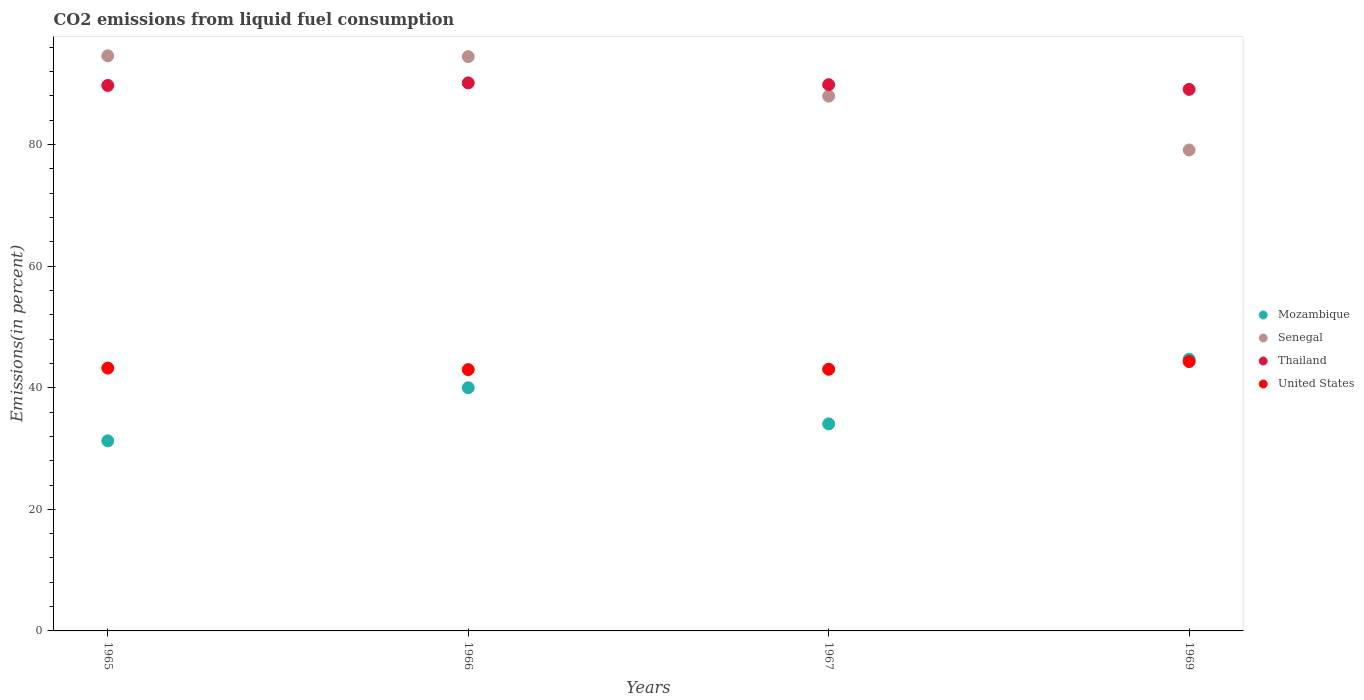How many different coloured dotlines are there?
Provide a succinct answer. 4. What is the total CO2 emitted in United States in 1969?
Make the answer very short. 44.3. Across all years, what is the maximum total CO2 emitted in Mozambique?
Your answer should be compact. 44.68. Across all years, what is the minimum total CO2 emitted in Mozambique?
Make the answer very short. 31.26. In which year was the total CO2 emitted in Senegal maximum?
Keep it short and to the point. 1965. In which year was the total CO2 emitted in Senegal minimum?
Provide a succinct answer. 1969. What is the total total CO2 emitted in United States in the graph?
Offer a terse response. 173.55. What is the difference between the total CO2 emitted in Mozambique in 1965 and that in 1967?
Your answer should be very brief. -2.79. What is the difference between the total CO2 emitted in Thailand in 1969 and the total CO2 emitted in United States in 1965?
Make the answer very short. 45.84. What is the average total CO2 emitted in United States per year?
Make the answer very short. 43.39. In the year 1969, what is the difference between the total CO2 emitted in Thailand and total CO2 emitted in Senegal?
Your answer should be compact. 9.97. In how many years, is the total CO2 emitted in United States greater than 92 %?
Keep it short and to the point. 0. What is the ratio of the total CO2 emitted in Mozambique in 1965 to that in 1966?
Offer a terse response. 0.78. Is the total CO2 emitted in United States in 1965 less than that in 1966?
Give a very brief answer. No. Is the difference between the total CO2 emitted in Thailand in 1965 and 1967 greater than the difference between the total CO2 emitted in Senegal in 1965 and 1967?
Offer a very short reply. No. What is the difference between the highest and the second highest total CO2 emitted in Senegal?
Offer a very short reply. 0.13. What is the difference between the highest and the lowest total CO2 emitted in Thailand?
Your answer should be very brief. 1.06. Is it the case that in every year, the sum of the total CO2 emitted in Senegal and total CO2 emitted in United States  is greater than the sum of total CO2 emitted in Mozambique and total CO2 emitted in Thailand?
Provide a succinct answer. No. Is it the case that in every year, the sum of the total CO2 emitted in Mozambique and total CO2 emitted in United States  is greater than the total CO2 emitted in Thailand?
Your answer should be very brief. No. Does the total CO2 emitted in Thailand monotonically increase over the years?
Provide a short and direct response. No. Is the total CO2 emitted in United States strictly less than the total CO2 emitted in Mozambique over the years?
Provide a short and direct response. No. How many dotlines are there?
Give a very brief answer. 4. How many years are there in the graph?
Ensure brevity in your answer.  4. What is the difference between two consecutive major ticks on the Y-axis?
Offer a terse response. 20. Are the values on the major ticks of Y-axis written in scientific E-notation?
Give a very brief answer. No. Does the graph contain any zero values?
Ensure brevity in your answer.  No. Where does the legend appear in the graph?
Your response must be concise. Center right. How many legend labels are there?
Provide a succinct answer. 4. How are the legend labels stacked?
Give a very brief answer. Vertical. What is the title of the graph?
Make the answer very short. CO2 emissions from liquid fuel consumption. What is the label or title of the Y-axis?
Your answer should be compact. Emissions(in percent). What is the Emissions(in percent) of Mozambique in 1965?
Your response must be concise. 31.26. What is the Emissions(in percent) in Senegal in 1965?
Keep it short and to the point. 94.59. What is the Emissions(in percent) in Thailand in 1965?
Offer a terse response. 89.71. What is the Emissions(in percent) of United States in 1965?
Your answer should be very brief. 43.23. What is the Emissions(in percent) of Senegal in 1966?
Give a very brief answer. 94.46. What is the Emissions(in percent) of Thailand in 1966?
Keep it short and to the point. 90.14. What is the Emissions(in percent) in United States in 1966?
Make the answer very short. 42.98. What is the Emissions(in percent) in Mozambique in 1967?
Make the answer very short. 34.05. What is the Emissions(in percent) in Senegal in 1967?
Provide a succinct answer. 87.96. What is the Emissions(in percent) of Thailand in 1967?
Your answer should be very brief. 89.84. What is the Emissions(in percent) of United States in 1967?
Ensure brevity in your answer.  43.04. What is the Emissions(in percent) of Mozambique in 1969?
Your answer should be compact. 44.68. What is the Emissions(in percent) in Senegal in 1969?
Provide a succinct answer. 79.1. What is the Emissions(in percent) of Thailand in 1969?
Offer a terse response. 89.07. What is the Emissions(in percent) of United States in 1969?
Make the answer very short. 44.3. Across all years, what is the maximum Emissions(in percent) in Mozambique?
Offer a terse response. 44.68. Across all years, what is the maximum Emissions(in percent) of Senegal?
Keep it short and to the point. 94.59. Across all years, what is the maximum Emissions(in percent) of Thailand?
Ensure brevity in your answer.  90.14. Across all years, what is the maximum Emissions(in percent) of United States?
Your answer should be very brief. 44.3. Across all years, what is the minimum Emissions(in percent) in Mozambique?
Provide a succinct answer. 31.26. Across all years, what is the minimum Emissions(in percent) of Senegal?
Make the answer very short. 79.1. Across all years, what is the minimum Emissions(in percent) in Thailand?
Keep it short and to the point. 89.07. Across all years, what is the minimum Emissions(in percent) in United States?
Offer a very short reply. 42.98. What is the total Emissions(in percent) of Mozambique in the graph?
Ensure brevity in your answer.  150. What is the total Emissions(in percent) in Senegal in the graph?
Keep it short and to the point. 356.11. What is the total Emissions(in percent) in Thailand in the graph?
Provide a short and direct response. 358.76. What is the total Emissions(in percent) in United States in the graph?
Give a very brief answer. 173.55. What is the difference between the Emissions(in percent) in Mozambique in 1965 and that in 1966?
Give a very brief answer. -8.74. What is the difference between the Emissions(in percent) in Senegal in 1965 and that in 1966?
Make the answer very short. 0.13. What is the difference between the Emissions(in percent) in Thailand in 1965 and that in 1966?
Ensure brevity in your answer.  -0.42. What is the difference between the Emissions(in percent) of United States in 1965 and that in 1966?
Ensure brevity in your answer.  0.25. What is the difference between the Emissions(in percent) in Mozambique in 1965 and that in 1967?
Provide a succinct answer. -2.79. What is the difference between the Emissions(in percent) of Senegal in 1965 and that in 1967?
Your answer should be compact. 6.63. What is the difference between the Emissions(in percent) in Thailand in 1965 and that in 1967?
Give a very brief answer. -0.13. What is the difference between the Emissions(in percent) in United States in 1965 and that in 1967?
Keep it short and to the point. 0.19. What is the difference between the Emissions(in percent) of Mozambique in 1965 and that in 1969?
Your response must be concise. -13.42. What is the difference between the Emissions(in percent) in Senegal in 1965 and that in 1969?
Keep it short and to the point. 15.48. What is the difference between the Emissions(in percent) of Thailand in 1965 and that in 1969?
Offer a terse response. 0.64. What is the difference between the Emissions(in percent) of United States in 1965 and that in 1969?
Provide a succinct answer. -1.07. What is the difference between the Emissions(in percent) of Mozambique in 1966 and that in 1967?
Keep it short and to the point. 5.95. What is the difference between the Emissions(in percent) in Senegal in 1966 and that in 1967?
Keep it short and to the point. 6.5. What is the difference between the Emissions(in percent) of Thailand in 1966 and that in 1967?
Ensure brevity in your answer.  0.29. What is the difference between the Emissions(in percent) in United States in 1966 and that in 1967?
Offer a terse response. -0.06. What is the difference between the Emissions(in percent) of Mozambique in 1966 and that in 1969?
Offer a terse response. -4.68. What is the difference between the Emissions(in percent) in Senegal in 1966 and that in 1969?
Provide a short and direct response. 15.35. What is the difference between the Emissions(in percent) in Thailand in 1966 and that in 1969?
Provide a short and direct response. 1.06. What is the difference between the Emissions(in percent) in United States in 1966 and that in 1969?
Offer a terse response. -1.32. What is the difference between the Emissions(in percent) of Mozambique in 1967 and that in 1969?
Your answer should be very brief. -10.63. What is the difference between the Emissions(in percent) of Senegal in 1967 and that in 1969?
Give a very brief answer. 8.85. What is the difference between the Emissions(in percent) of Thailand in 1967 and that in 1969?
Offer a terse response. 0.77. What is the difference between the Emissions(in percent) of United States in 1967 and that in 1969?
Keep it short and to the point. -1.27. What is the difference between the Emissions(in percent) of Mozambique in 1965 and the Emissions(in percent) of Senegal in 1966?
Offer a terse response. -63.19. What is the difference between the Emissions(in percent) in Mozambique in 1965 and the Emissions(in percent) in Thailand in 1966?
Ensure brevity in your answer.  -58.87. What is the difference between the Emissions(in percent) of Mozambique in 1965 and the Emissions(in percent) of United States in 1966?
Offer a terse response. -11.72. What is the difference between the Emissions(in percent) in Senegal in 1965 and the Emissions(in percent) in Thailand in 1966?
Offer a very short reply. 4.45. What is the difference between the Emissions(in percent) of Senegal in 1965 and the Emissions(in percent) of United States in 1966?
Your answer should be very brief. 51.61. What is the difference between the Emissions(in percent) in Thailand in 1965 and the Emissions(in percent) in United States in 1966?
Give a very brief answer. 46.73. What is the difference between the Emissions(in percent) in Mozambique in 1965 and the Emissions(in percent) in Senegal in 1967?
Your response must be concise. -56.7. What is the difference between the Emissions(in percent) in Mozambique in 1965 and the Emissions(in percent) in Thailand in 1967?
Offer a very short reply. -58.58. What is the difference between the Emissions(in percent) of Mozambique in 1965 and the Emissions(in percent) of United States in 1967?
Your answer should be very brief. -11.77. What is the difference between the Emissions(in percent) in Senegal in 1965 and the Emissions(in percent) in Thailand in 1967?
Your answer should be very brief. 4.75. What is the difference between the Emissions(in percent) in Senegal in 1965 and the Emissions(in percent) in United States in 1967?
Provide a succinct answer. 51.55. What is the difference between the Emissions(in percent) of Thailand in 1965 and the Emissions(in percent) of United States in 1967?
Keep it short and to the point. 46.68. What is the difference between the Emissions(in percent) of Mozambique in 1965 and the Emissions(in percent) of Senegal in 1969?
Provide a succinct answer. -47.84. What is the difference between the Emissions(in percent) in Mozambique in 1965 and the Emissions(in percent) in Thailand in 1969?
Offer a very short reply. -57.81. What is the difference between the Emissions(in percent) in Mozambique in 1965 and the Emissions(in percent) in United States in 1969?
Your response must be concise. -13.04. What is the difference between the Emissions(in percent) of Senegal in 1965 and the Emissions(in percent) of Thailand in 1969?
Provide a succinct answer. 5.52. What is the difference between the Emissions(in percent) in Senegal in 1965 and the Emissions(in percent) in United States in 1969?
Provide a short and direct response. 50.29. What is the difference between the Emissions(in percent) of Thailand in 1965 and the Emissions(in percent) of United States in 1969?
Give a very brief answer. 45.41. What is the difference between the Emissions(in percent) in Mozambique in 1966 and the Emissions(in percent) in Senegal in 1967?
Your response must be concise. -47.96. What is the difference between the Emissions(in percent) in Mozambique in 1966 and the Emissions(in percent) in Thailand in 1967?
Your response must be concise. -49.84. What is the difference between the Emissions(in percent) of Mozambique in 1966 and the Emissions(in percent) of United States in 1967?
Give a very brief answer. -3.04. What is the difference between the Emissions(in percent) in Senegal in 1966 and the Emissions(in percent) in Thailand in 1967?
Offer a very short reply. 4.61. What is the difference between the Emissions(in percent) in Senegal in 1966 and the Emissions(in percent) in United States in 1967?
Your answer should be very brief. 51.42. What is the difference between the Emissions(in percent) in Thailand in 1966 and the Emissions(in percent) in United States in 1967?
Your answer should be compact. 47.1. What is the difference between the Emissions(in percent) in Mozambique in 1966 and the Emissions(in percent) in Senegal in 1969?
Keep it short and to the point. -39.1. What is the difference between the Emissions(in percent) in Mozambique in 1966 and the Emissions(in percent) in Thailand in 1969?
Offer a very short reply. -49.07. What is the difference between the Emissions(in percent) in Mozambique in 1966 and the Emissions(in percent) in United States in 1969?
Make the answer very short. -4.3. What is the difference between the Emissions(in percent) of Senegal in 1966 and the Emissions(in percent) of Thailand in 1969?
Provide a short and direct response. 5.39. What is the difference between the Emissions(in percent) in Senegal in 1966 and the Emissions(in percent) in United States in 1969?
Make the answer very short. 50.15. What is the difference between the Emissions(in percent) of Thailand in 1966 and the Emissions(in percent) of United States in 1969?
Ensure brevity in your answer.  45.83. What is the difference between the Emissions(in percent) of Mozambique in 1967 and the Emissions(in percent) of Senegal in 1969?
Provide a succinct answer. -45.05. What is the difference between the Emissions(in percent) in Mozambique in 1967 and the Emissions(in percent) in Thailand in 1969?
Provide a succinct answer. -55.02. What is the difference between the Emissions(in percent) in Mozambique in 1967 and the Emissions(in percent) in United States in 1969?
Provide a short and direct response. -10.25. What is the difference between the Emissions(in percent) of Senegal in 1967 and the Emissions(in percent) of Thailand in 1969?
Ensure brevity in your answer.  -1.11. What is the difference between the Emissions(in percent) of Senegal in 1967 and the Emissions(in percent) of United States in 1969?
Ensure brevity in your answer.  43.66. What is the difference between the Emissions(in percent) in Thailand in 1967 and the Emissions(in percent) in United States in 1969?
Keep it short and to the point. 45.54. What is the average Emissions(in percent) of Mozambique per year?
Offer a very short reply. 37.5. What is the average Emissions(in percent) of Senegal per year?
Ensure brevity in your answer.  89.03. What is the average Emissions(in percent) of Thailand per year?
Provide a short and direct response. 89.69. What is the average Emissions(in percent) of United States per year?
Make the answer very short. 43.39. In the year 1965, what is the difference between the Emissions(in percent) in Mozambique and Emissions(in percent) in Senegal?
Provide a short and direct response. -63.33. In the year 1965, what is the difference between the Emissions(in percent) in Mozambique and Emissions(in percent) in Thailand?
Offer a very short reply. -58.45. In the year 1965, what is the difference between the Emissions(in percent) in Mozambique and Emissions(in percent) in United States?
Give a very brief answer. -11.97. In the year 1965, what is the difference between the Emissions(in percent) of Senegal and Emissions(in percent) of Thailand?
Offer a very short reply. 4.87. In the year 1965, what is the difference between the Emissions(in percent) of Senegal and Emissions(in percent) of United States?
Offer a terse response. 51.36. In the year 1965, what is the difference between the Emissions(in percent) of Thailand and Emissions(in percent) of United States?
Your answer should be compact. 46.48. In the year 1966, what is the difference between the Emissions(in percent) in Mozambique and Emissions(in percent) in Senegal?
Your answer should be very brief. -54.46. In the year 1966, what is the difference between the Emissions(in percent) of Mozambique and Emissions(in percent) of Thailand?
Your answer should be compact. -50.14. In the year 1966, what is the difference between the Emissions(in percent) of Mozambique and Emissions(in percent) of United States?
Your answer should be very brief. -2.98. In the year 1966, what is the difference between the Emissions(in percent) of Senegal and Emissions(in percent) of Thailand?
Your answer should be compact. 4.32. In the year 1966, what is the difference between the Emissions(in percent) of Senegal and Emissions(in percent) of United States?
Provide a short and direct response. 51.48. In the year 1966, what is the difference between the Emissions(in percent) in Thailand and Emissions(in percent) in United States?
Ensure brevity in your answer.  47.15. In the year 1967, what is the difference between the Emissions(in percent) of Mozambique and Emissions(in percent) of Senegal?
Your response must be concise. -53.91. In the year 1967, what is the difference between the Emissions(in percent) of Mozambique and Emissions(in percent) of Thailand?
Keep it short and to the point. -55.79. In the year 1967, what is the difference between the Emissions(in percent) in Mozambique and Emissions(in percent) in United States?
Offer a very short reply. -8.99. In the year 1967, what is the difference between the Emissions(in percent) in Senegal and Emissions(in percent) in Thailand?
Your response must be concise. -1.89. In the year 1967, what is the difference between the Emissions(in percent) of Senegal and Emissions(in percent) of United States?
Give a very brief answer. 44.92. In the year 1967, what is the difference between the Emissions(in percent) in Thailand and Emissions(in percent) in United States?
Your response must be concise. 46.81. In the year 1969, what is the difference between the Emissions(in percent) in Mozambique and Emissions(in percent) in Senegal?
Offer a very short reply. -34.42. In the year 1969, what is the difference between the Emissions(in percent) of Mozambique and Emissions(in percent) of Thailand?
Your answer should be compact. -44.39. In the year 1969, what is the difference between the Emissions(in percent) of Mozambique and Emissions(in percent) of United States?
Your answer should be compact. 0.38. In the year 1969, what is the difference between the Emissions(in percent) of Senegal and Emissions(in percent) of Thailand?
Ensure brevity in your answer.  -9.97. In the year 1969, what is the difference between the Emissions(in percent) of Senegal and Emissions(in percent) of United States?
Your answer should be compact. 34.8. In the year 1969, what is the difference between the Emissions(in percent) of Thailand and Emissions(in percent) of United States?
Your answer should be very brief. 44.77. What is the ratio of the Emissions(in percent) of Mozambique in 1965 to that in 1966?
Ensure brevity in your answer.  0.78. What is the ratio of the Emissions(in percent) in Senegal in 1965 to that in 1966?
Offer a terse response. 1. What is the ratio of the Emissions(in percent) in United States in 1965 to that in 1966?
Your answer should be very brief. 1.01. What is the ratio of the Emissions(in percent) of Mozambique in 1965 to that in 1967?
Make the answer very short. 0.92. What is the ratio of the Emissions(in percent) of Senegal in 1965 to that in 1967?
Offer a terse response. 1.08. What is the ratio of the Emissions(in percent) of Mozambique in 1965 to that in 1969?
Provide a succinct answer. 0.7. What is the ratio of the Emissions(in percent) in Senegal in 1965 to that in 1969?
Provide a short and direct response. 1.2. What is the ratio of the Emissions(in percent) of United States in 1965 to that in 1969?
Make the answer very short. 0.98. What is the ratio of the Emissions(in percent) in Mozambique in 1966 to that in 1967?
Your answer should be very brief. 1.17. What is the ratio of the Emissions(in percent) in Senegal in 1966 to that in 1967?
Make the answer very short. 1.07. What is the ratio of the Emissions(in percent) of Mozambique in 1966 to that in 1969?
Your response must be concise. 0.9. What is the ratio of the Emissions(in percent) of Senegal in 1966 to that in 1969?
Your response must be concise. 1.19. What is the ratio of the Emissions(in percent) of Thailand in 1966 to that in 1969?
Give a very brief answer. 1.01. What is the ratio of the Emissions(in percent) of United States in 1966 to that in 1969?
Make the answer very short. 0.97. What is the ratio of the Emissions(in percent) in Mozambique in 1967 to that in 1969?
Your answer should be very brief. 0.76. What is the ratio of the Emissions(in percent) in Senegal in 1967 to that in 1969?
Offer a very short reply. 1.11. What is the ratio of the Emissions(in percent) of Thailand in 1967 to that in 1969?
Provide a short and direct response. 1.01. What is the ratio of the Emissions(in percent) of United States in 1967 to that in 1969?
Offer a terse response. 0.97. What is the difference between the highest and the second highest Emissions(in percent) of Mozambique?
Provide a short and direct response. 4.68. What is the difference between the highest and the second highest Emissions(in percent) of Senegal?
Give a very brief answer. 0.13. What is the difference between the highest and the second highest Emissions(in percent) of Thailand?
Your response must be concise. 0.29. What is the difference between the highest and the second highest Emissions(in percent) in United States?
Ensure brevity in your answer.  1.07. What is the difference between the highest and the lowest Emissions(in percent) of Mozambique?
Your response must be concise. 13.42. What is the difference between the highest and the lowest Emissions(in percent) in Senegal?
Your response must be concise. 15.48. What is the difference between the highest and the lowest Emissions(in percent) of Thailand?
Offer a very short reply. 1.06. What is the difference between the highest and the lowest Emissions(in percent) of United States?
Your answer should be very brief. 1.32. 